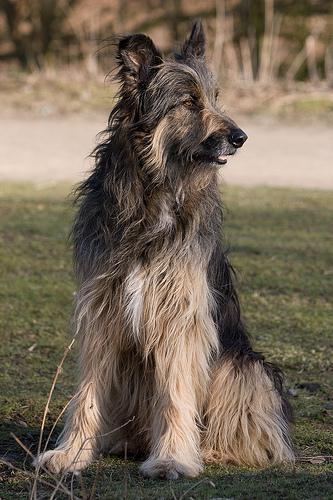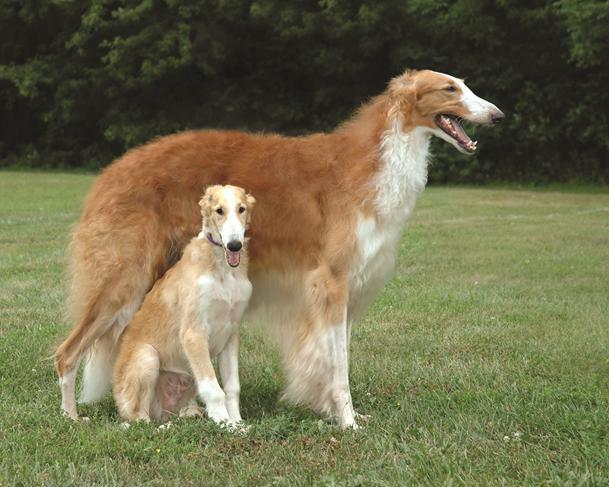The first image is the image on the left, the second image is the image on the right. Examine the images to the left and right. Is the description "One image shows a single dog standing in grass." accurate? Answer yes or no. No. The first image is the image on the left, the second image is the image on the right. Examine the images to the left and right. Is the description "An image shows exactly two pet hounds on grass." accurate? Answer yes or no. Yes. 